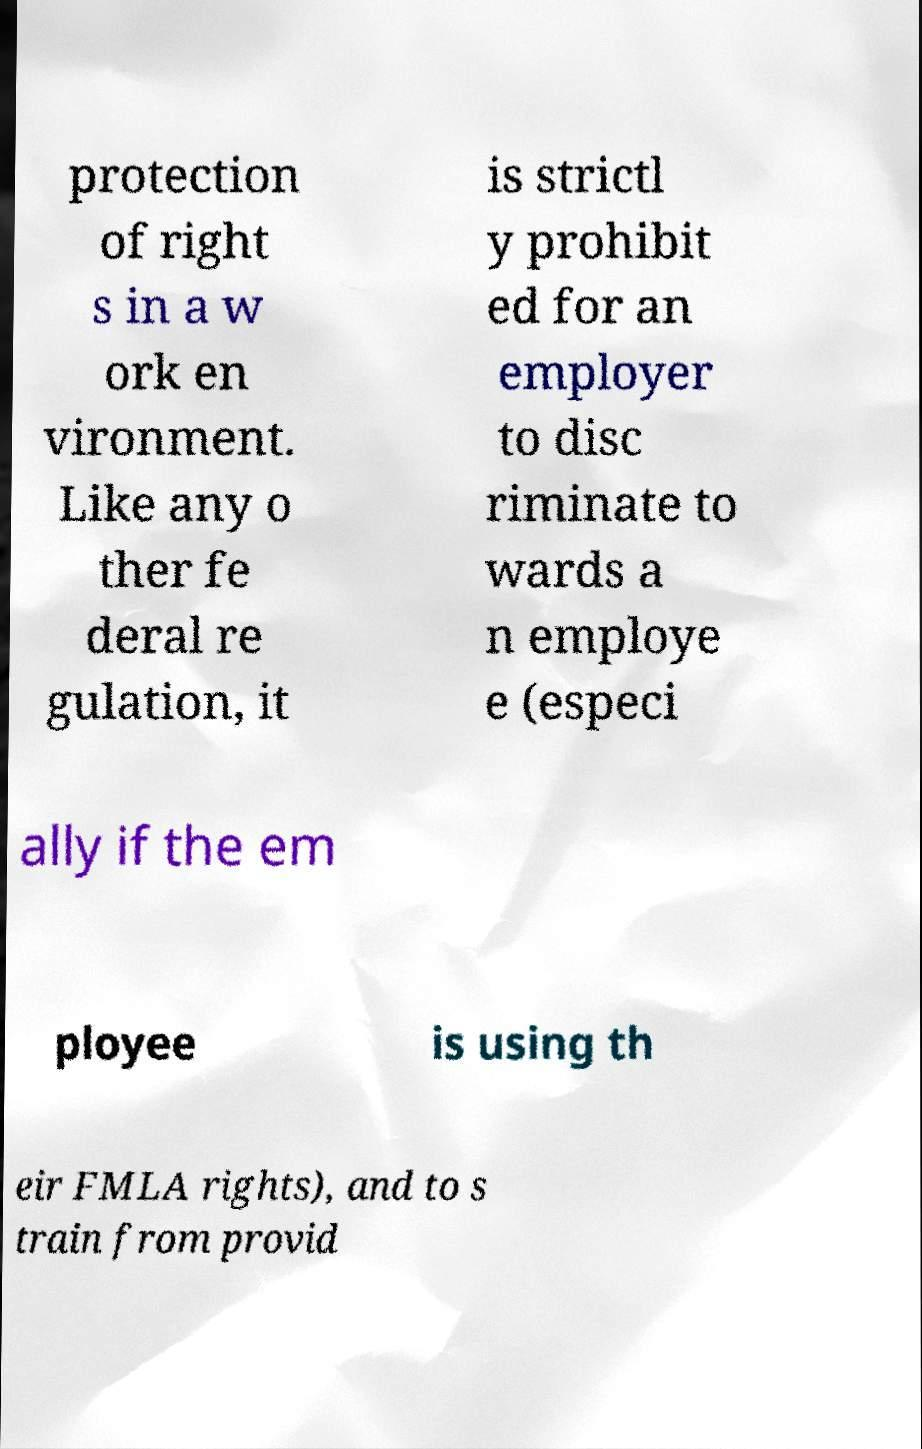Please identify and transcribe the text found in this image. protection of right s in a w ork en vironment. Like any o ther fe deral re gulation, it is strictl y prohibit ed for an employer to disc riminate to wards a n employe e (especi ally if the em ployee is using th eir FMLA rights), and to s train from provid 